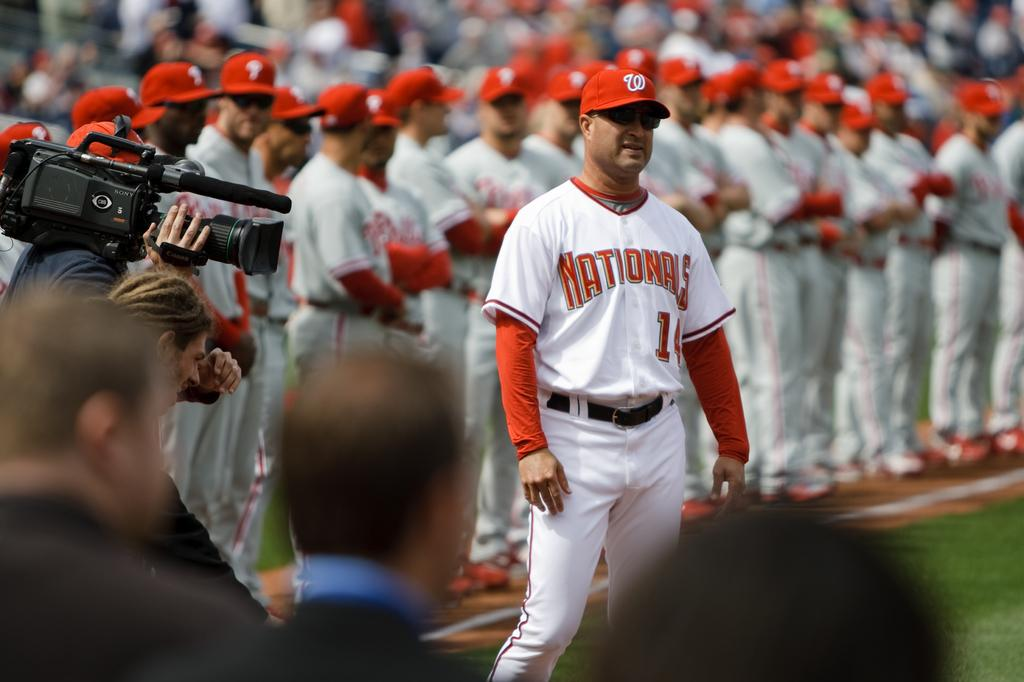<image>
Render a clear and concise summary of the photo. Nationals player number 1 front and center with his teammates behind him. 